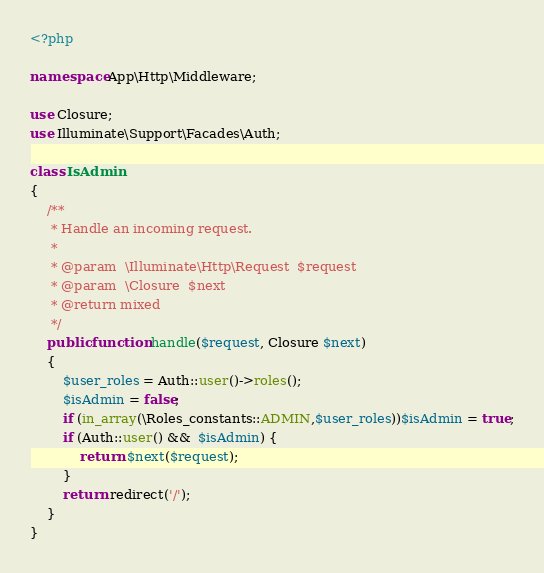Convert code to text. <code><loc_0><loc_0><loc_500><loc_500><_PHP_><?php

namespace App\Http\Middleware;

use Closure;
use Illuminate\Support\Facades\Auth;

class IsAdmin
{
    /**
     * Handle an incoming request.
     *
     * @param  \Illuminate\Http\Request  $request
     * @param  \Closure  $next
     * @return mixed
     */
    public function handle($request, Closure $next)
    {
        $user_roles = Auth::user()->roles();
        $isAdmin = false;
        if (in_array(\Roles_constants::ADMIN,$user_roles))$isAdmin = true;
        if (Auth::user() &&  $isAdmin) {
            return $next($request);
        }
        return redirect('/');
    }
}
</code> 